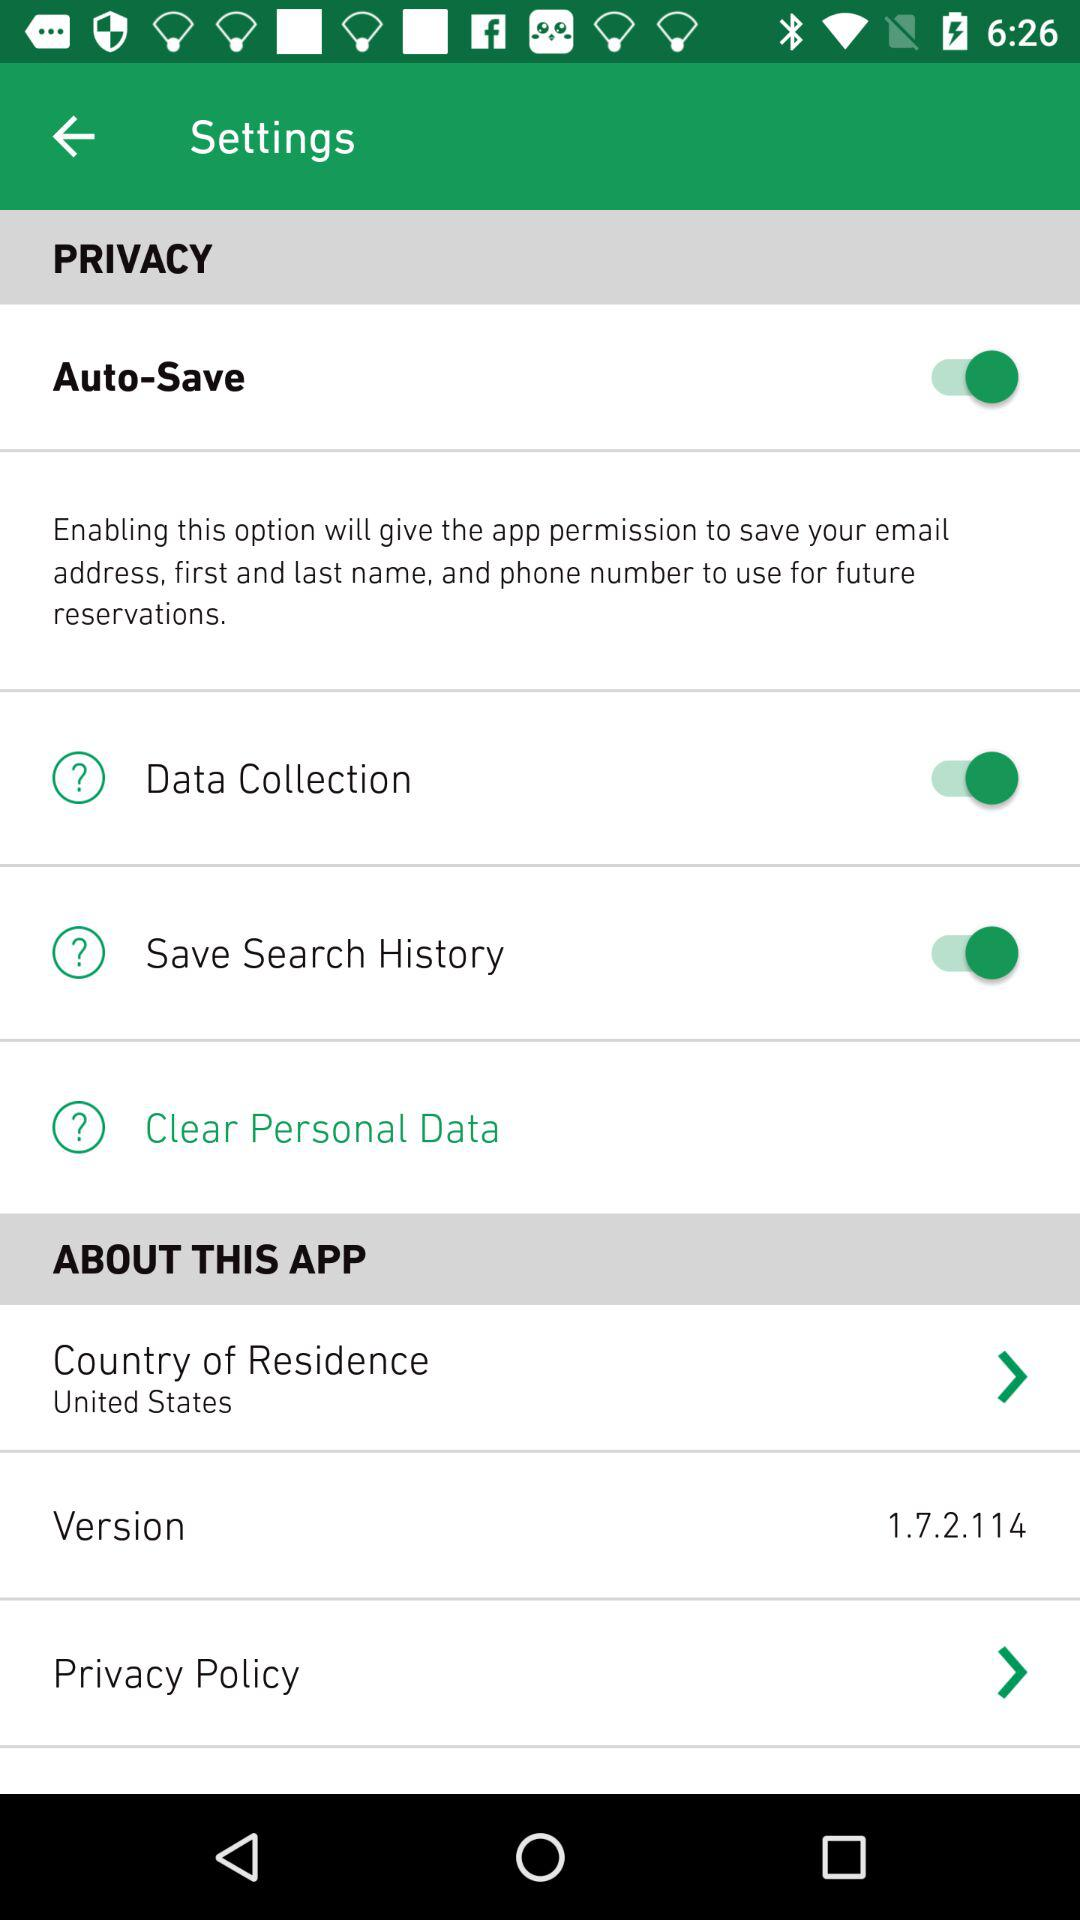What is the version of the app? The version is 1.7.2.114. 